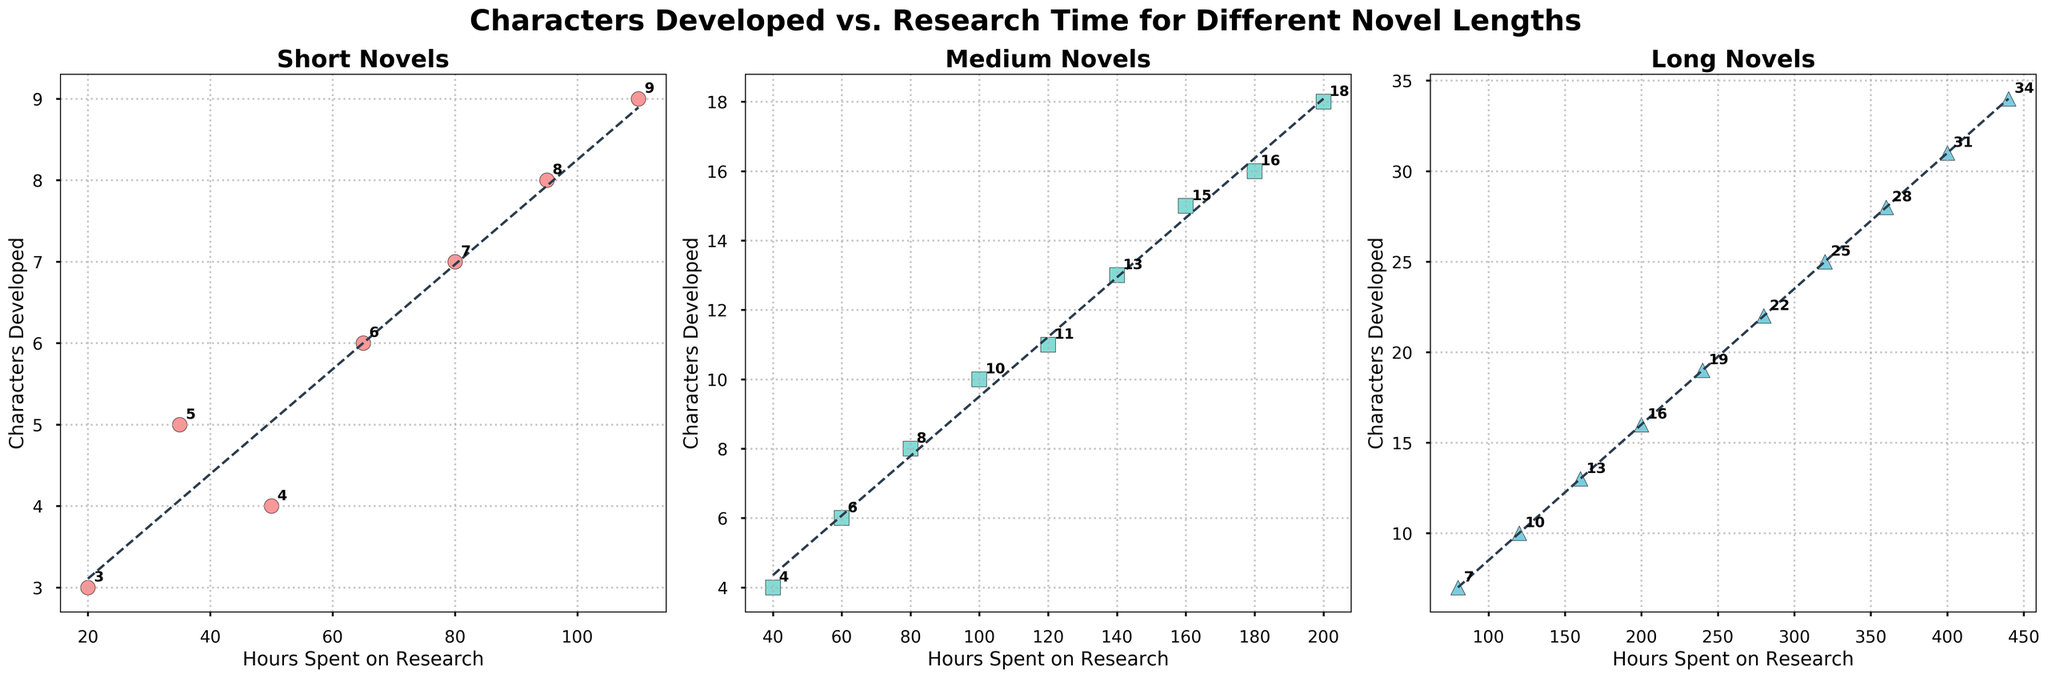How are the trends in characters developed as research hours increase different between short, medium, and long novels? The scatter plot shows an increasing trend line for characters developed as research hours increase across all three novel lengths. The slope of the trend lines gets steeper as novels get longer, indicating that for longer novels, characters developed increase more rapidly with research hours compared to shorter novels.
Answer: Longer novels show a steeper increase Which subplot has the highest range of characters developed? By examining the scatter plots, notice that the range of characters developed for 'Long' novels is from 7 to 34 while 'Medium' ranges from 4 to 18 and 'Short' from 3 to 9. Hence, the range is highest in the 'Long' novels subplot.
Answer: Long novels What is the highest number of characters developed in short novels? In the subplot for short novels, the highest number of characters developed is shown at the topmost data point, which is 9.
Answer: 9 Which category of novels shows the most clustering around a specific number of research hours? In the medium novels subplot, many data points are clustered between 60 and 100 hours of research. This clustering indicates most medium novels have characters developed around the same research hours.
Answer: Medium novels What is the difference in the maximum number of characters developed between short and long novels? The maximum number of characters developed in short novels is 9, while in long novels, it is 34. The difference is 34 - 9 = 25.
Answer: 25 What is the average number of characters developed in medium novels? In the medium novels subplot, the number of characters developed are [4, 6, 8, 10, 11, 13, 15, 16, 18]. Adding these gives 101 and dividing by 9 gives roughly 11.22.
Answer: 11.22 Which subplot has the least steep trend line? By comparing the slope of the trend lines in all three subplots, the short novels subplot has the least steep trend line, indicating a slower increase in characters developed as research hours increase.
Answer: Short novels How does the number of characters developed change from 80 to 200 hours in long novels? In long novels, characters developed increase from 7 to 16 between 80 and 200 hours. This change equates to an increase of 16 - 7 = 9 characters.
Answer: Increase by 9 What color represents the data points for medium novels? The data points in the medium novels subplot are shown in a greenish-blue color.
Answer: Greenish-blue 